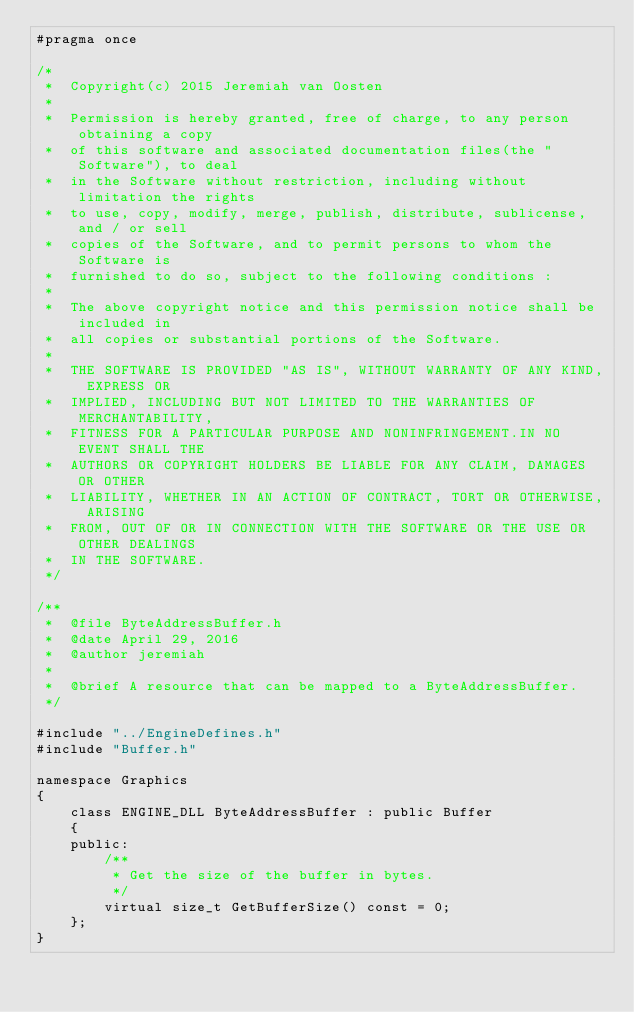<code> <loc_0><loc_0><loc_500><loc_500><_C_>#pragma once

/*
 *  Copyright(c) 2015 Jeremiah van Oosten
 *
 *  Permission is hereby granted, free of charge, to any person obtaining a copy
 *  of this software and associated documentation files(the "Software"), to deal
 *  in the Software without restriction, including without limitation the rights
 *  to use, copy, modify, merge, publish, distribute, sublicense, and / or sell
 *  copies of the Software, and to permit persons to whom the Software is
 *  furnished to do so, subject to the following conditions :
 *
 *  The above copyright notice and this permission notice shall be included in
 *  all copies or substantial portions of the Software.
 *
 *  THE SOFTWARE IS PROVIDED "AS IS", WITHOUT WARRANTY OF ANY KIND, EXPRESS OR
 *  IMPLIED, INCLUDING BUT NOT LIMITED TO THE WARRANTIES OF MERCHANTABILITY,
 *  FITNESS FOR A PARTICULAR PURPOSE AND NONINFRINGEMENT.IN NO EVENT SHALL THE
 *  AUTHORS OR COPYRIGHT HOLDERS BE LIABLE FOR ANY CLAIM, DAMAGES OR OTHER
 *  LIABILITY, WHETHER IN AN ACTION OF CONTRACT, TORT OR OTHERWISE, ARISING
 *  FROM, OUT OF OR IN CONNECTION WITH THE SOFTWARE OR THE USE OR OTHER DEALINGS
 *  IN THE SOFTWARE.
 */

/**
 *  @file ByteAddressBuffer.h
 *  @date April 29, 2016
 *  @author jeremiah
 *
 *  @brief A resource that can be mapped to a ByteAddressBuffer.
 */

#include "../EngineDefines.h"
#include "Buffer.h"

namespace Graphics
{
    class ENGINE_DLL ByteAddressBuffer : public Buffer
    {
    public:
        /**
         * Get the size of the buffer in bytes.
         */
        virtual size_t GetBufferSize() const = 0;
    };
}
</code> 